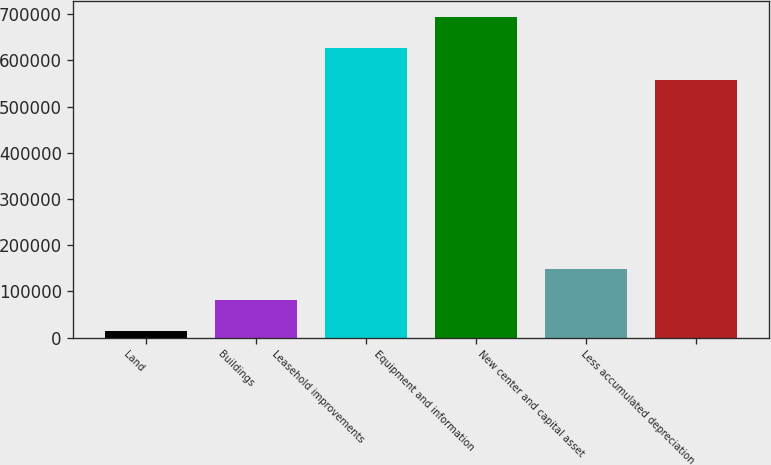Convert chart. <chart><loc_0><loc_0><loc_500><loc_500><bar_chart><fcel>Land<fcel>Buildings<fcel>Leasehold improvements<fcel>Equipment and information<fcel>New center and capital asset<fcel>Less accumulated depreciation<nl><fcel>13593<fcel>80876.3<fcel>626004<fcel>693288<fcel>148160<fcel>558721<nl></chart> 